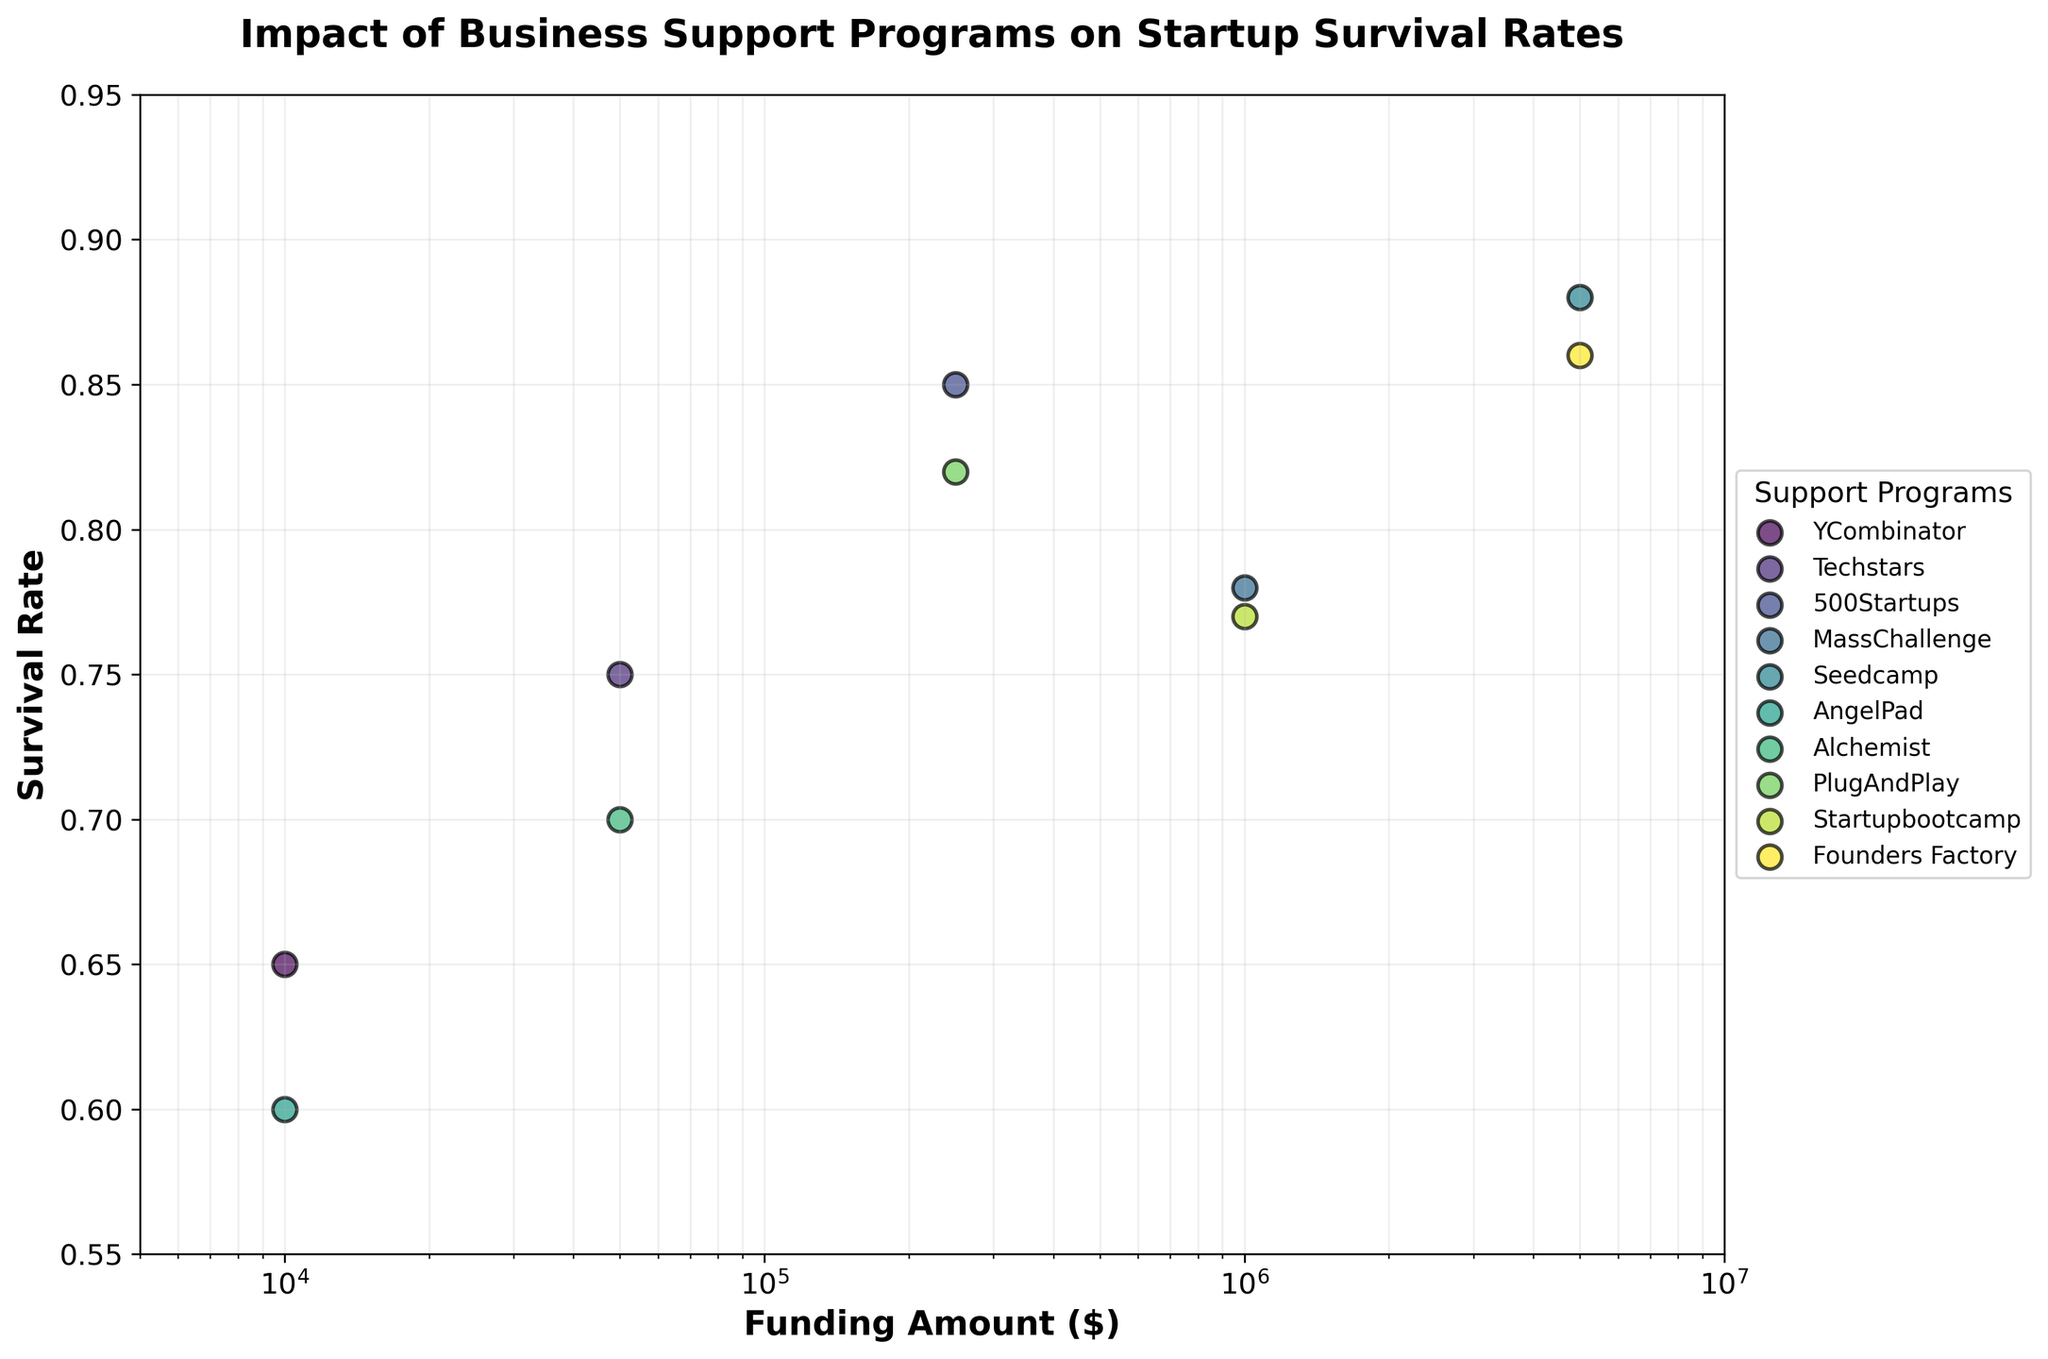What is the title of the figure? The title is usually placed at the top of the figure and provides a summary of what the plot is about. Here, it's clearly stated at the top.
Answer: Impact of Business Support Programs on Startup Survival Rates Which program has the highest survival rate for startups? To find the highest survival rate, we look at the y-values of the scatter plot and identify the program associated with the highest point. Seedcamp has the highest survival rate of 0.88.
Answer: Seedcamp What are the axes labels? The axes labels are usually located along the x-axis and y-axis giving context to the values plotted. The x-axis label is "Funding Amount ($)", and the y-axis label is "Survival Rate".
Answer: Funding Amount ($) and Survival Rate Which program received the highest funding amount, and what was their survival rate? The highest funding amount corresponds to the right-most point on the x-axis, which belongs to Seedcamp with $5,000,000 in funding. The survival rate for Seedcamp is 0.88.
Answer: Seedcamp, 0.88 Compare the survival rates between YCombinator and AngelPad. Which program has a higher survival rate and by how much? YCombinator has a survival rate of 0.65, while AngelPad has 0.60. The difference is found by subtracting AngelPad's rate from YCombinator's rate, 0.65 - 0.60.
Answer: YCombinator, 0.05 What is the ratio of the funding amounts between Techstars and PlugAndPlay? Techstars has a funding amount of $50,000, and PlugAndPlay has $250,000. The ratio is calculated as $250,000 / $50,000.
Answer: 5 Find the average survival rate of the programs with funding amounts of $1,000,000. The programs at this funding level are MassChallenge and Startupbootcamp with survival rates of 0.78 and 0.77, respectively. The average is calculated as (0.78 + 0.77) / 2.
Answer: 0.775 How do survival rates change with increasing funding amounts based on the figure? By observing the trend in the scatter plot, survival rates generally increase with higher funding amounts but with some fluctuations among specific programs.
Answer: Increase with fluctuations Which program at the $250,000 funding level has the higher survival rate? The two programs at this funding level are 500Startups and PlugAndPlay with survival rates of 0.85 and 0.82, respectively. 500Startups has the higher rate.
Answer: 500Startups What is the funding range covered in the figure? The range of funding amounts displayed in the figure extends from $10,000 to $5,000,000. This is evident from the points plotted on the x-axis.
Answer: $10,000 to $5,000,000 